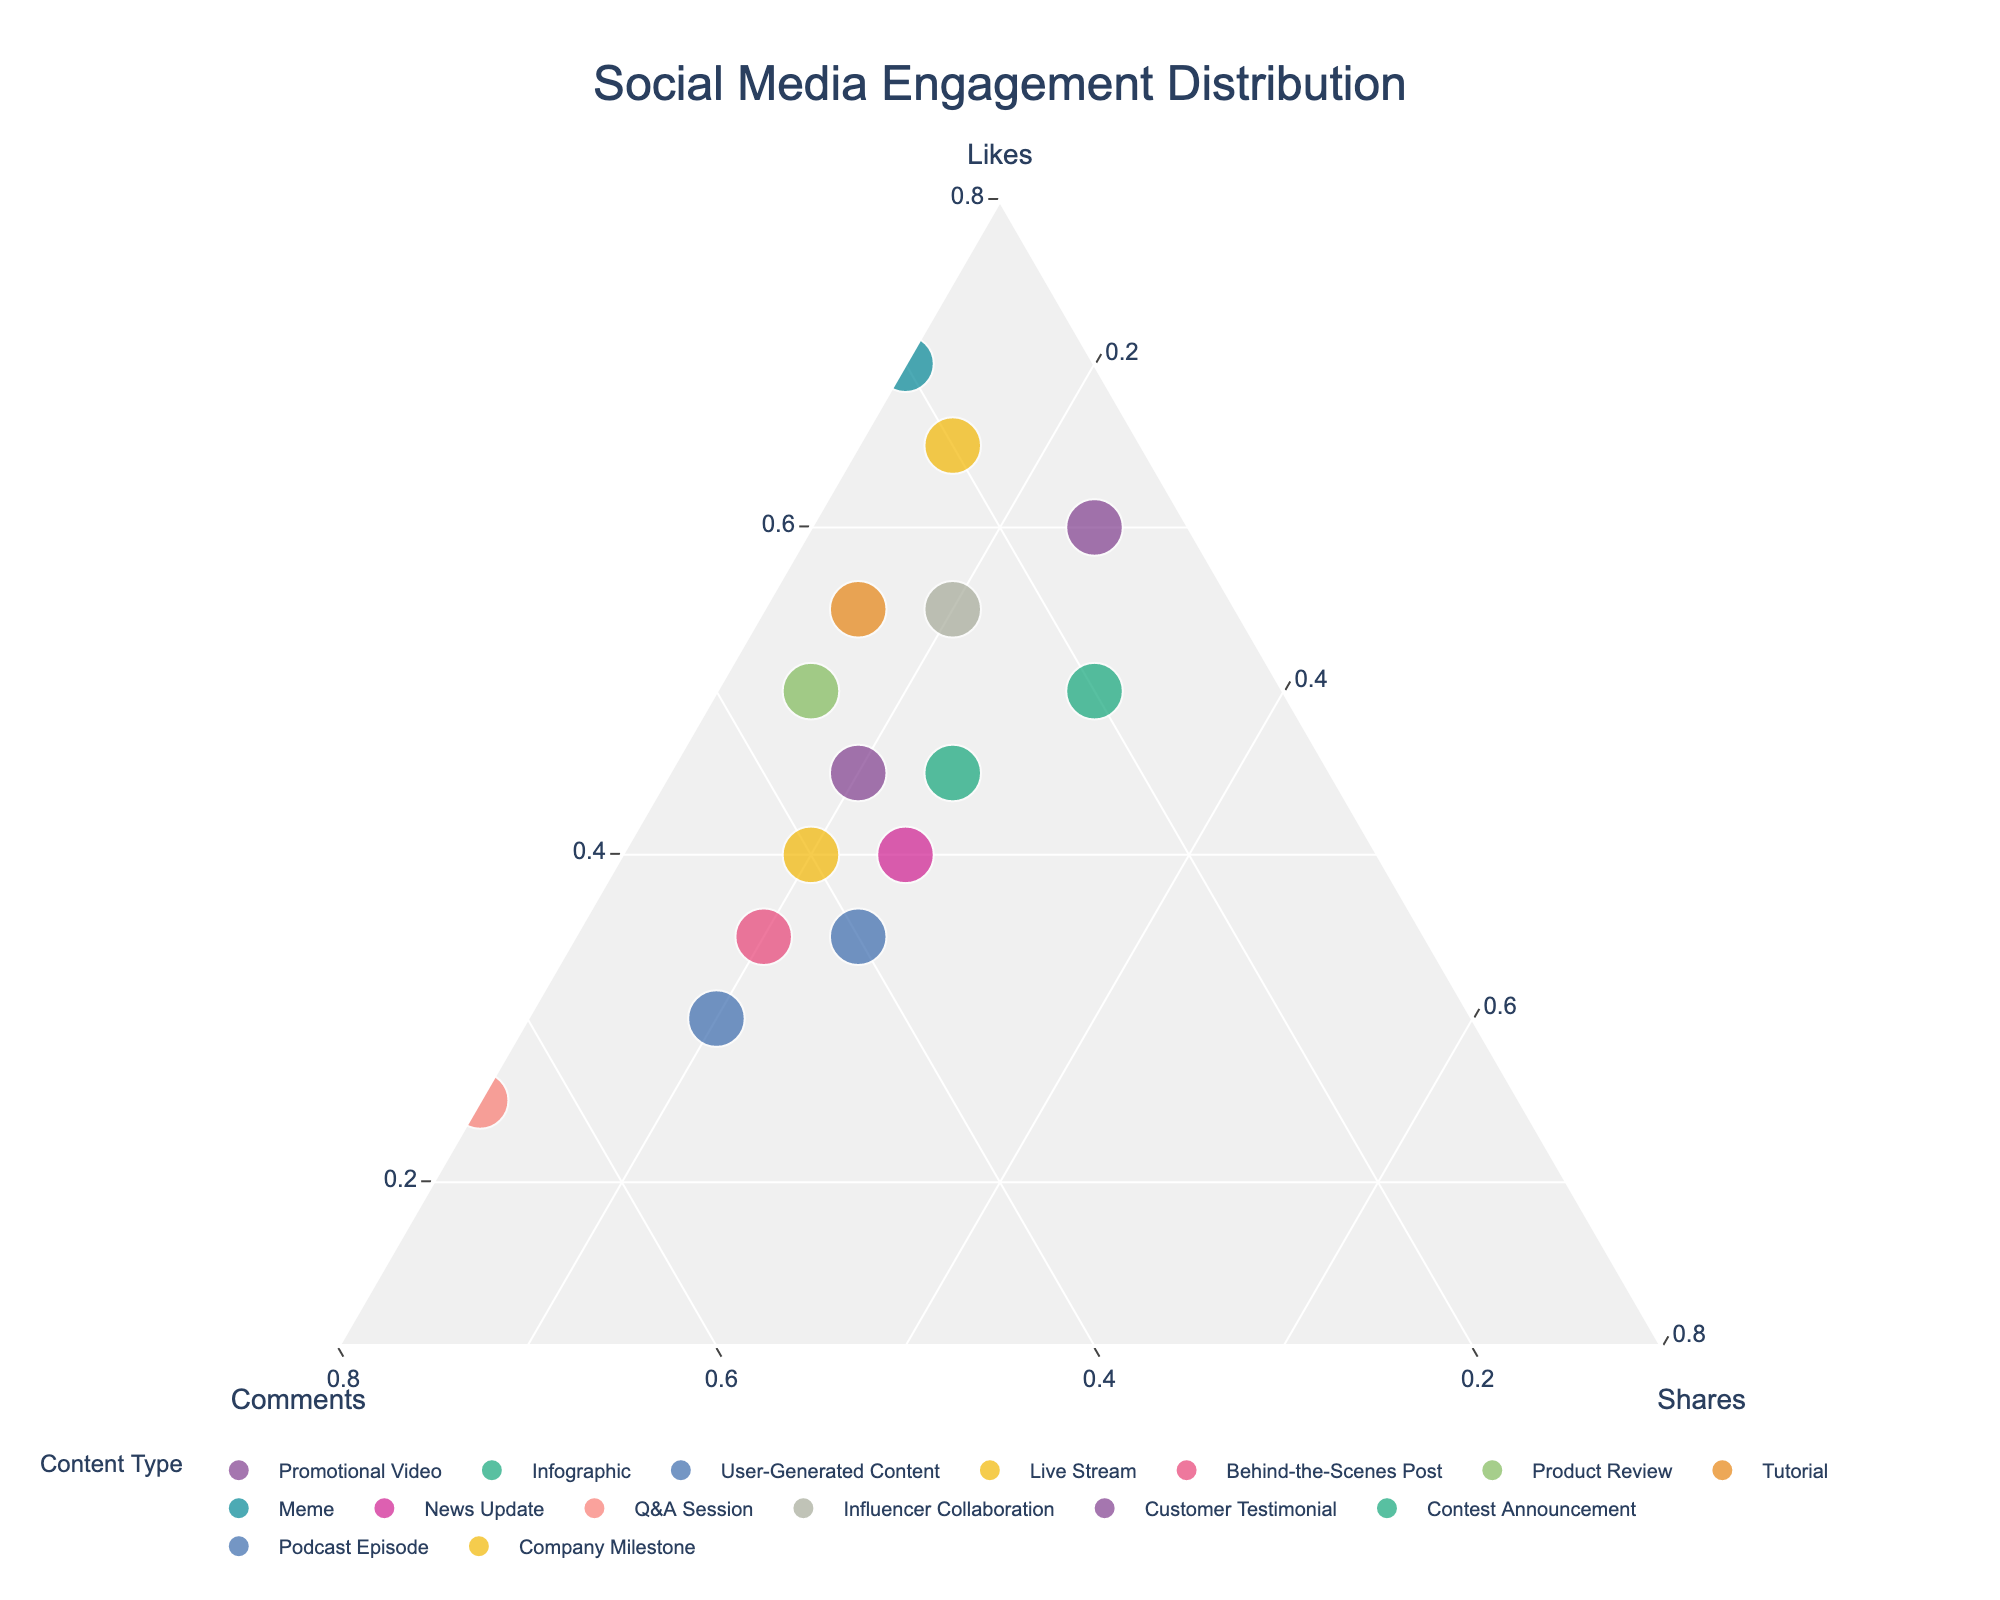What's the title of the plot? The title is located at the top center of the plot, usually in a larger font size compared to other text elements. It explains the main topic the plot is about.
Answer: Social Media Engagement Distribution Which content type has the highest percentage of Likes? Looking at the point that is closest to the "Likes" vertex of the ternary plot, we can determine the content type with the highest percentage of Likes. The Meme content type is closest to this vertex.
Answer: Meme How do Infographics and Q&A Sessions compare in terms of the percentage of Comments? Observe the positions of the points representing Infographics and Q&A Sessions relative to the "Comments" axis of the ternary plot. Q&A Sessions have a higher percentage of Comments since they're closer to the Comments vertex.
Answer: Q&A Sessions have more comments Which content type balances equally across Likes, Comments, and Shares? A point balanced equally across Likes, Comments, and Shares would be positioned near the center of the ternary plot. No content type is exactly at the center, but Live Stream is closest to balancing equally among all three.
Answer: Live Stream What percentage of the Promotional Video content is made up of Shares? Locate the Promotional Video point and identify its position relative to the "Shares" axis. The point is closer to the Likes and Comments vertices, indicating a lower percentage of Shares.
Answer: 25% What's the difference in the percentage of Comments between User-Generated Content and Behind-the-Scenes Post? Identify the positions of the points for User-Generated Content and Behind-the-Scenes Post relative to the "Comments" axis, and calculate the percentage difference. User-Generated Content has 50% for Comments, Behind-the-Scenes Post has 45%, thus the difference is \(50\% - 45\% = 5\%\).
Answer: 5% Which content type has the least engagement in Shares? Look for the point closest to the "Shares" axis, indicating a lower percentage of Shares. The Meme content type is closest to this axis.
Answer: Meme Is there any content type that has more than 60% engagement in any single category? Check the points closest to any one of the three vertices, as these points represent content types with high engagement in that particular category. Meme is near the Likes vertex, indicating more than 60% in Likes.
Answer: Yes, Meme for Likes What is the average percentage of Likes for Tutorial and Product Review contents? Find the position of the points for Tutorial and Product Review relative to the "Likes" axis. Tutorial has 55% and Product Review has 50% in Likes. Calculate the average: \((55\% + 50\%) / 2 = 52.5\%\).
Answer: 52.5% Which content type shows a more balanced distribution between Likes and Shares? Compare the points for various content types, looking specifically for those equidistant from the Likes and Shares vertices. Behind-the-Scenes Post appears more balanced between these two.
Answer: Behind-the-Scenes Post 